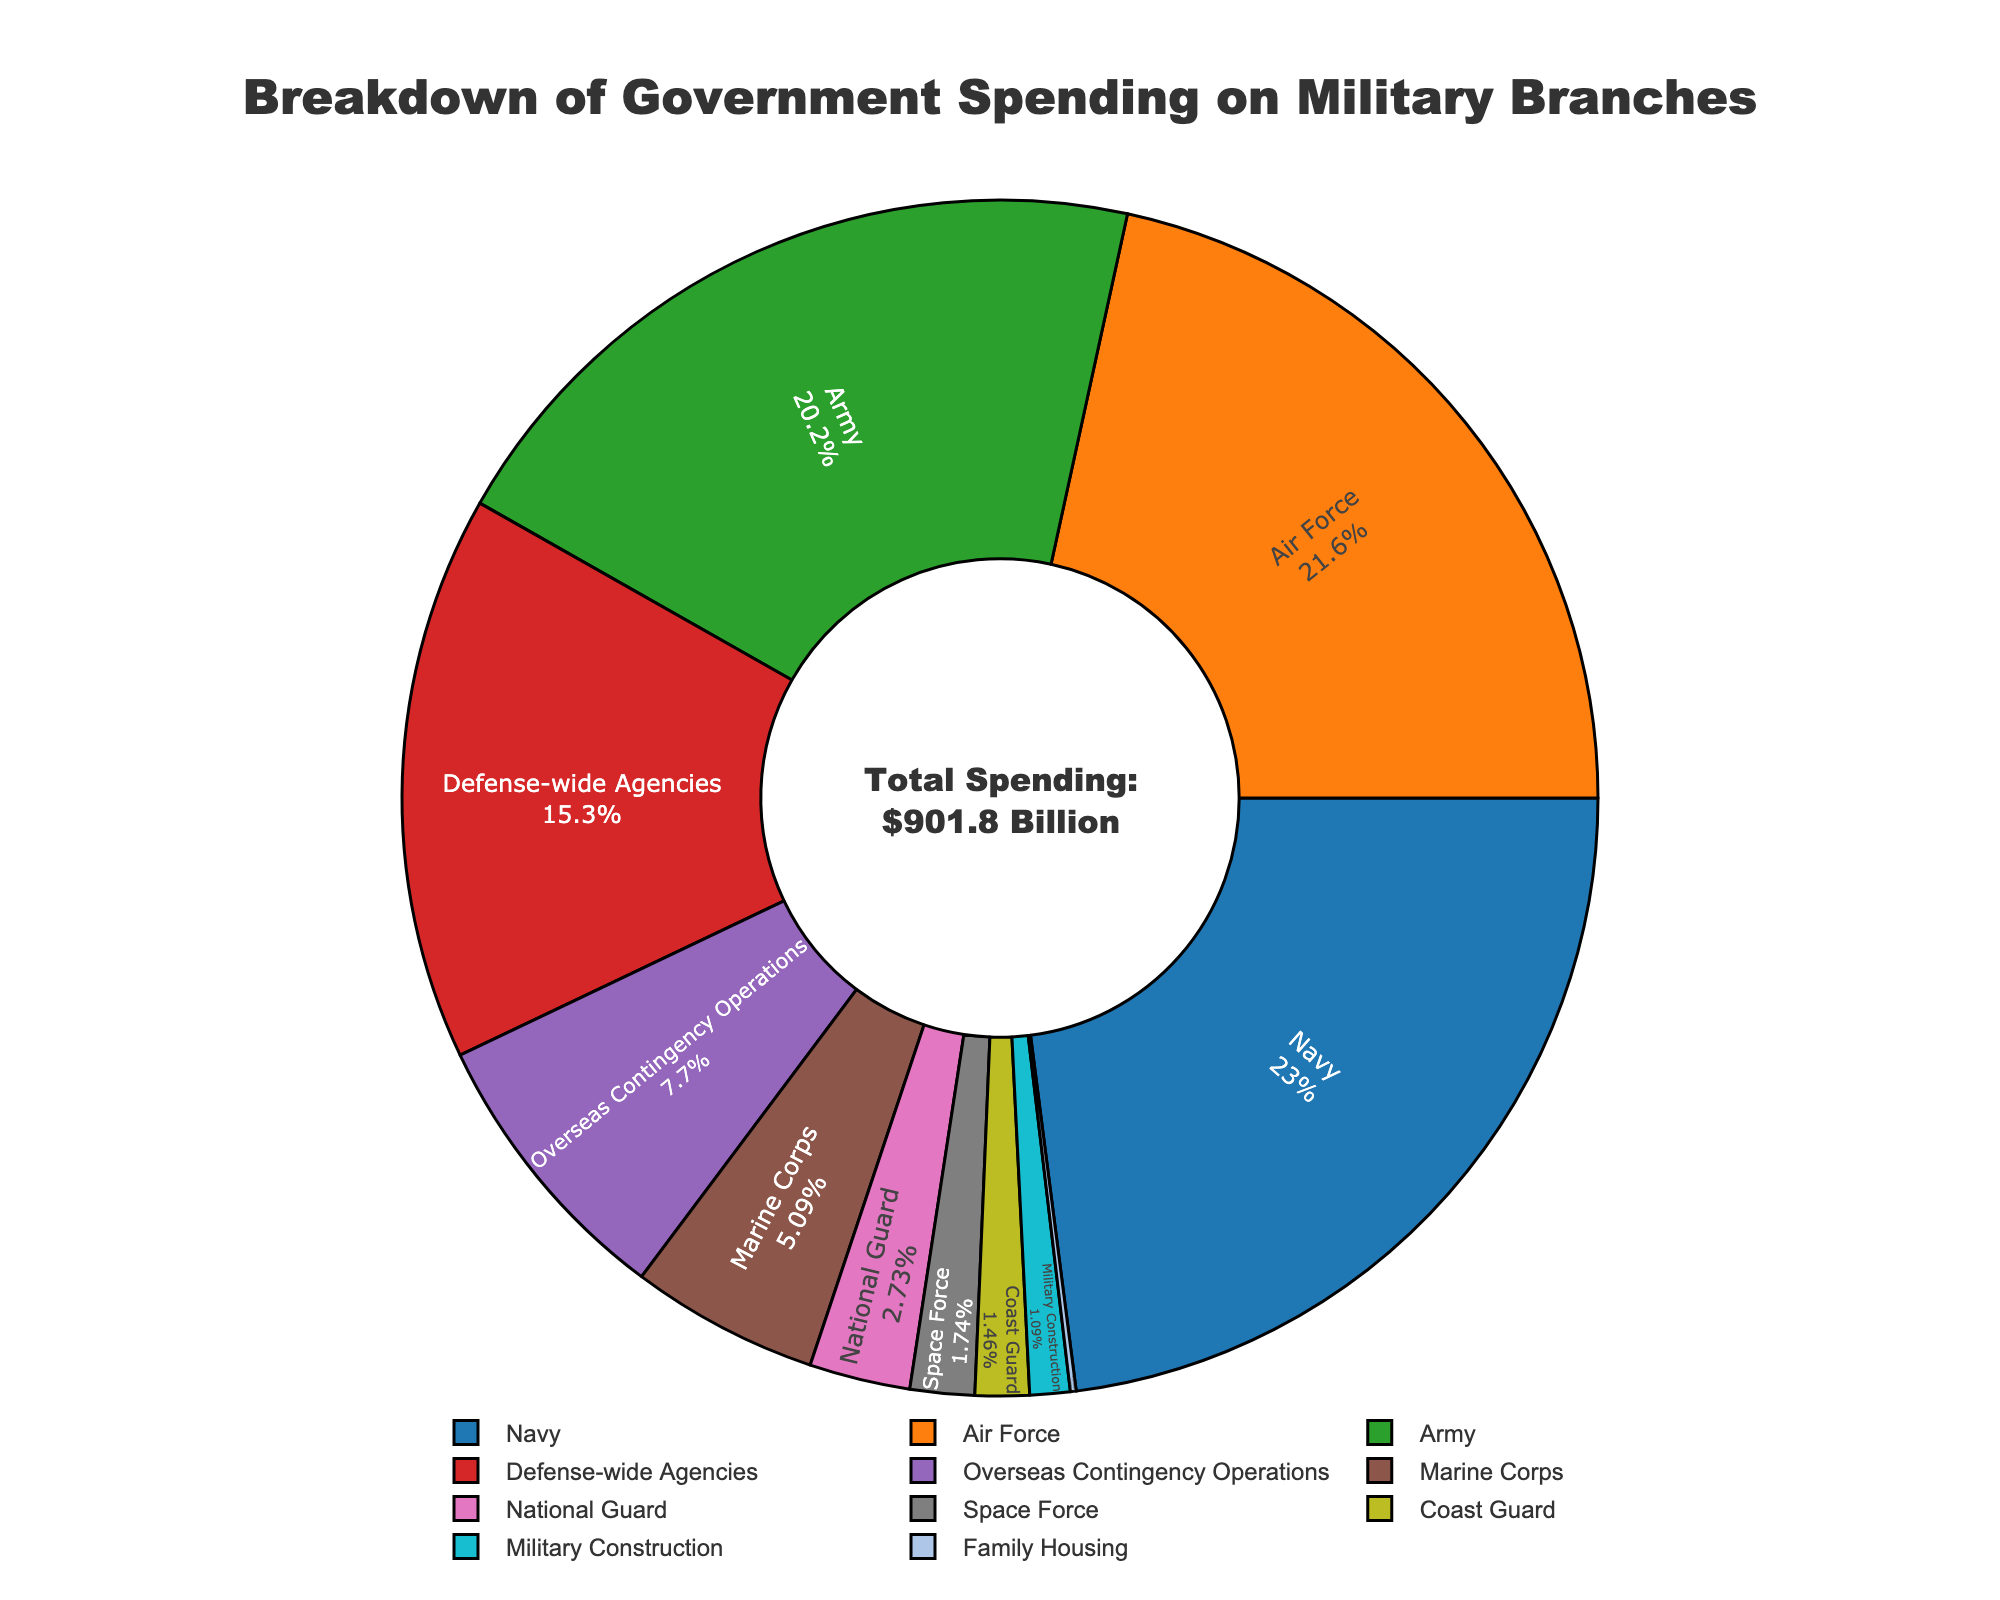What is the total spending on the Army and Air Force combined? To find the total spending on the Army and Air Force, sum up their respective spending amounts: $182.3 billion (Army) + $194.6 billion (Air Force) = $376.9 billion
Answer: $376.9 billion Which branch received the highest amount of funding? Examine the figure and find the segment with the largest percentage or highest value. The Navy has the highest spending at $207.1 billion
Answer: Navy What is the combined spending of the Marine Corps, Space Force, and Coast Guard? Add the spending of the Marine Corps ($45.9 billion), Space Force ($15.7 billion), and Coast Guard ($13.2 billion): $45.9 billion + $15.7 billion + $13.2 billion = $74.8 billion
Answer: $74.8 billion How does the spending on Overseas Contingency Operations compare to that of Defense-wide Agencies? Compare the spending amounts: Overseas Contingency Operations is $69.4 billion and Defense-wide Agencies is $137.8 billion. Defense-wide Agencies spending is higher
Answer: Defense-wide Agencies is higher What percent of total spending is allocated to National Guard? To find the percentage, divide the National Guard spending by the total spending, then multiply by 100. The total spending is the sum of all branches' spending: $901.8 billion. The spending on National Guard is $24.6 billion. So, ($24.6 billion / $901.8 billion) * 100 ≈ 2.7%
Answer: 2.7% Which branches have a spending less than $20 billion? Look for segments of the pie chart with spending under $20 billion: Space Force ($15.7 billion), Coast Guard ($13.2 billion), Military Construction ($9.8 billion), and Family Housing ($1.4 billion)
Answer: Space Force, Coast Guard, Military Construction, Family Housing What's the difference in spending between the Navy and the Coast Guard? Subtract Coast Guard spending from Navy spending: $207.1 billion (Navy) - $13.2 billion (Coast Guard) = $193.9 billion
Answer: $193.9 billion What is the average spending for branches with more than $100 billion in funding? Identify the branches with more than $100 billion: Army ($182.3 billion), Navy ($207.1 billion), Air Force ($194.6 billion), and Defense-wide Agencies ($137.8 billion). Sum these values and divide by the number of branches: ($182.3 billion + $207.1 billion + $194.6 billion + $137.8 billion) / 4 = $180.45 billion
Answer: $180.45 billion Which sector has the smallest allocation, and what amount was allocated to it? Identify the smallest segment in the pie chart. The smallest allocation is Family Housing at $1.4 billion
Answer: Family Housing, $1.4 billion 